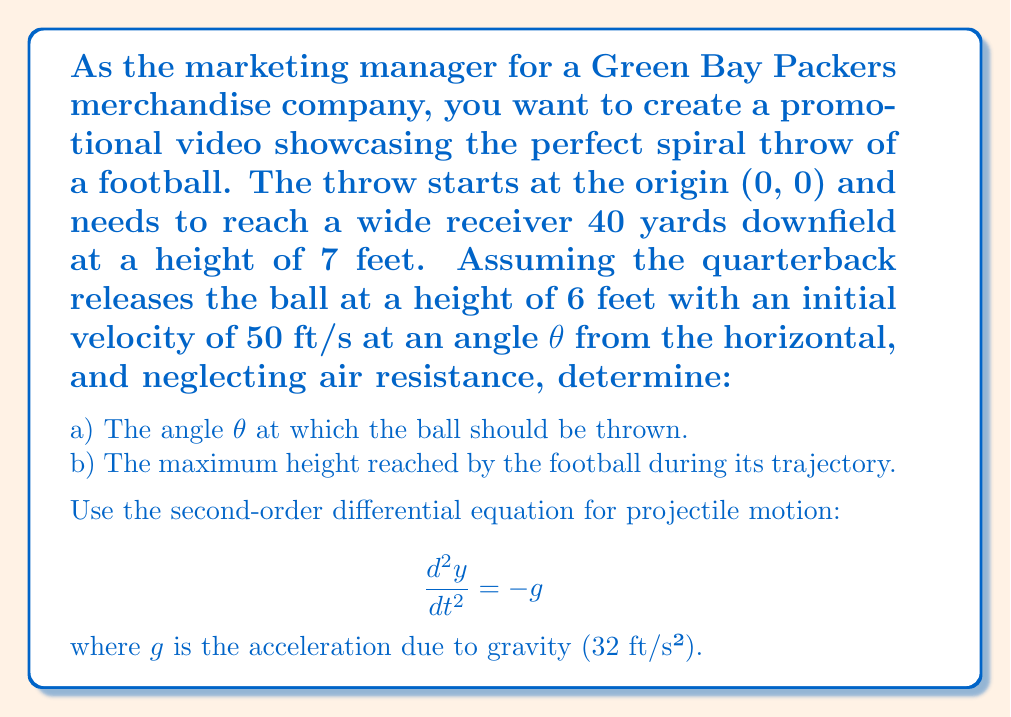Could you help me with this problem? Let's approach this step-by-step:

1) The equations of motion for a projectile are:

   $$x = v_0 \cos(\theta) t$$
   $$y = 6 + v_0 \sin(\theta) t - \frac{1}{2}gt^2$$

   where $v_0 = 50$ ft/s and $g = 32$ ft/s².

2) We know that when the ball reaches the receiver:
   x = 120 ft (40 yards)
   y = 7 ft
   
3) Using the x-equation:
   $$120 = 50 \cos(\theta) t$$
   $$t = \frac{120}{50 \cos(\theta)} = \frac{12}{5 \cos(\theta)}$$

4) Substituting this into the y-equation:
   $$7 = 6 + 50 \sin(\theta) \frac{12}{5 \cos(\theta)} - \frac{1}{2}(32)(\frac{12}{5 \cos(\theta)})^2$$

5) Simplifying:
   $$1 = 12 \tan(\theta) - \frac{9.216}{\cos^2(\theta)}$$

6) This equation can be solved numerically to find θ ≈ 10.47°

7) For the maximum height, we use the equation:
   $$y_{max} = 6 + \frac{v_0^2 \sin^2(\theta)}{2g}$$

8) Substituting our values:
   $$y_{max} = 6 + \frac{50^2 \sin^2(10.47°)}{2(32)} \approx 11.65 \text{ ft}$$
Answer: a) The angle θ at which the ball should be thrown is approximately 10.47°.
b) The maximum height reached by the football during its trajectory is approximately 11.65 feet. 